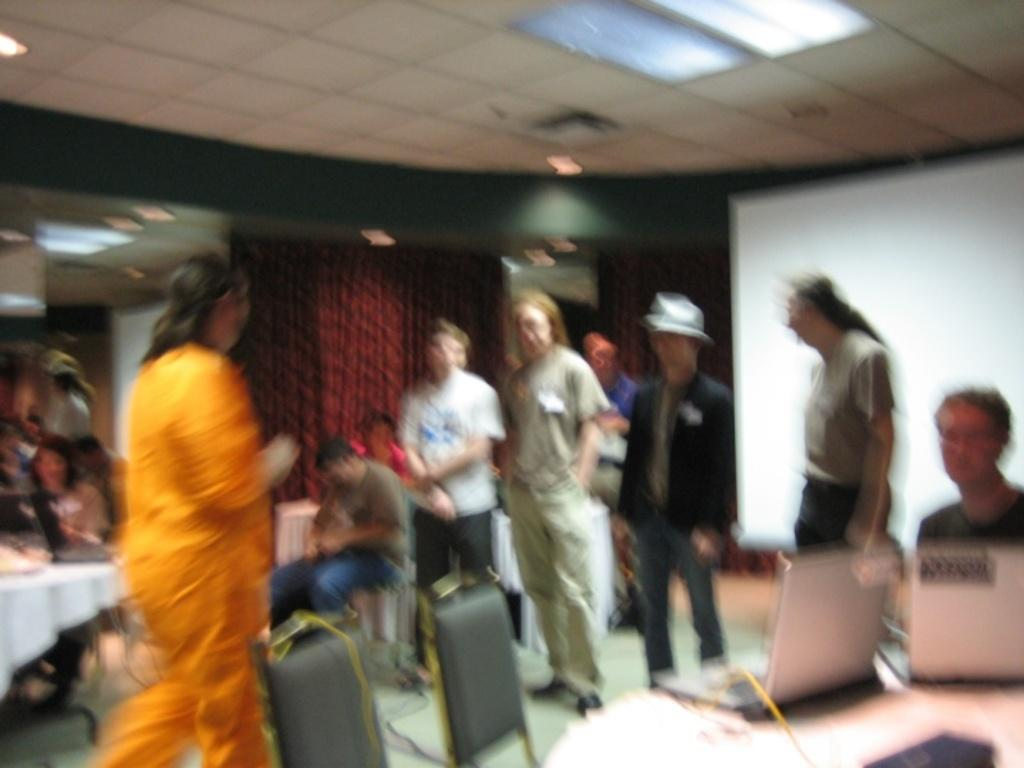What is the overall quality of the image? The image is blurred. Can you identify any subjects in the image? Yes, there are people in the image. What objects are present on the desk in the image? There are laptops on a desk in the image. What is the purpose of the projector screen in the image? The projector screen is likely used for presentations or displaying visuals. What type of window treatment is visible in the image? There are curtains in the image. What type of seating is available in the image? There are chairs in the image. What is visible on the ceiling in the image? The roof with lights is visible in the image. What type of vessel is being used by the people in the image? There is no vessel present in the image; it features people, laptops, a projector screen, curtains, chairs, and a roof with lights. What book is the person holding in the image? There is no book visible in the image. 